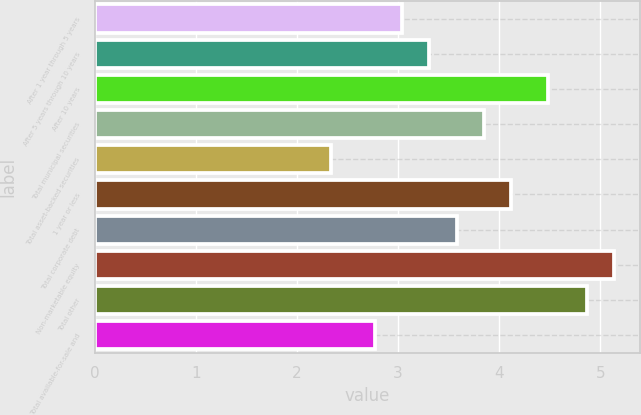Convert chart. <chart><loc_0><loc_0><loc_500><loc_500><bar_chart><fcel>After 1 year through 5 years<fcel>After 5 years through 10 years<fcel>After 10 years<fcel>Total municipal securities<fcel>Total asset-backed securities<fcel>1 year or less<fcel>Total corporate debt<fcel>Non-marketable equity<fcel>Total other<fcel>Total available-for-sale and<nl><fcel>3.04<fcel>3.31<fcel>4.48<fcel>3.85<fcel>2.34<fcel>4.12<fcel>3.58<fcel>5.14<fcel>4.87<fcel>2.77<nl></chart> 